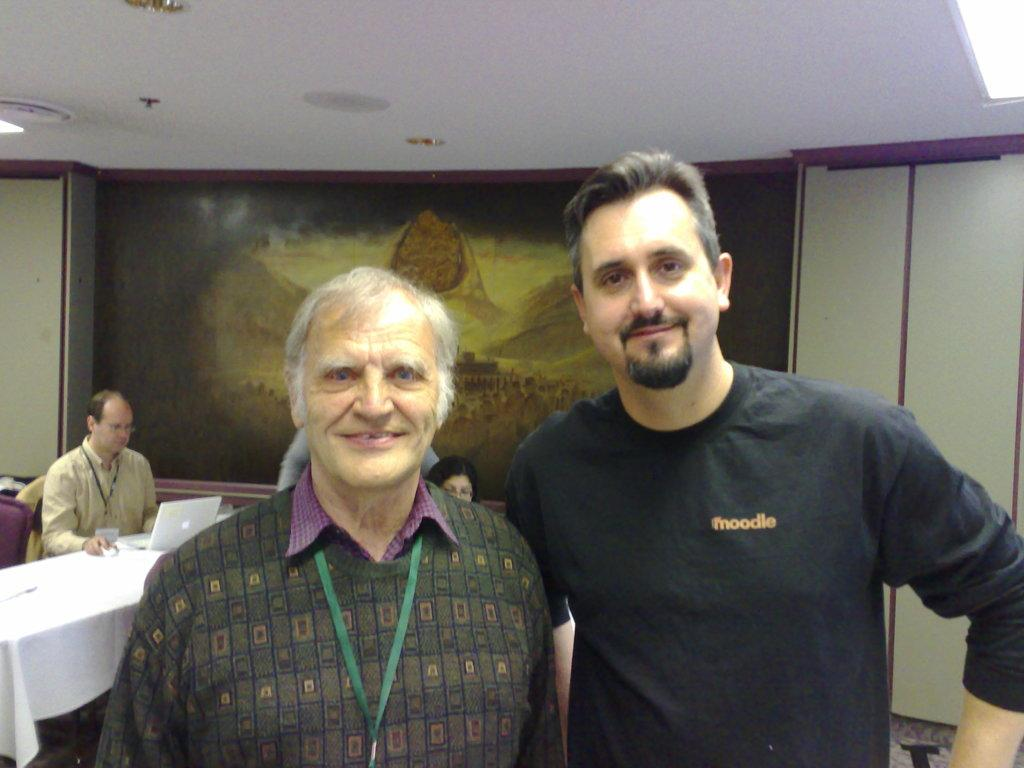How many people are in the image? There are two persons in the image. What are the persons doing in the image? The persons are looking at the camera. What can be seen in the background of the image? There is a scenery in the background of the image. What type of rifle can be seen in the hands of the persons in the image? There is no rifle present in the image; the persons are looking at the camera without any visible objects in their hands. 